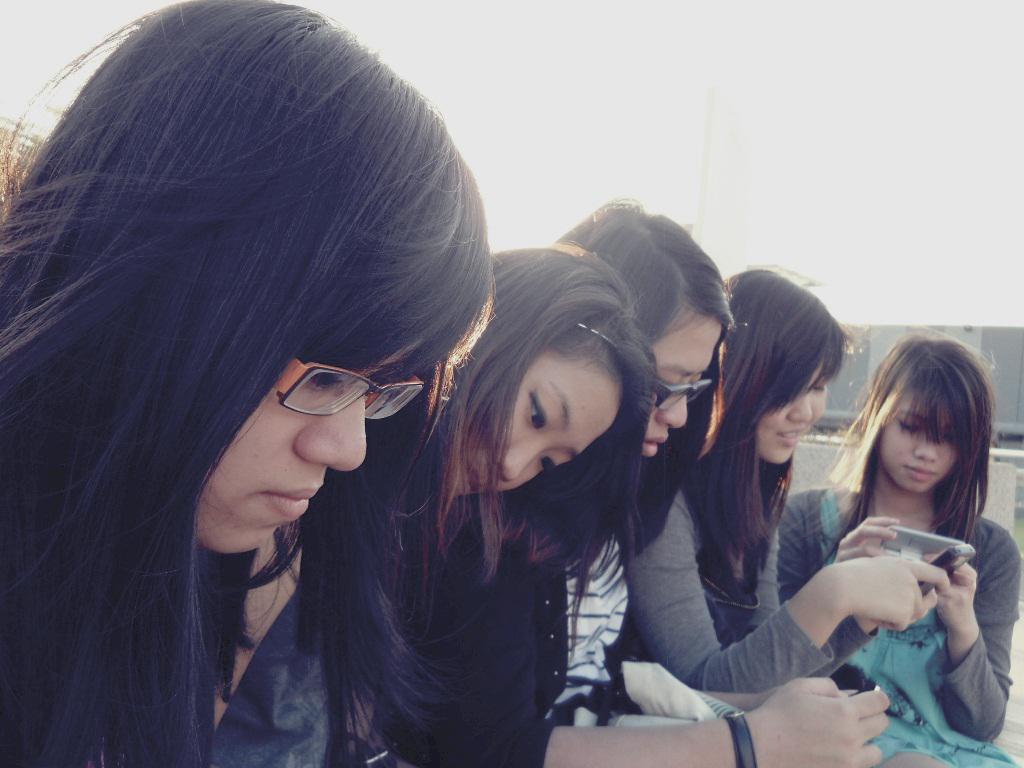In one or two sentences, can you explain what this image depicts? In this picture we can see there are groups of people on the path and some people holding the mobiles. Behind the people there is an object and a sky. 